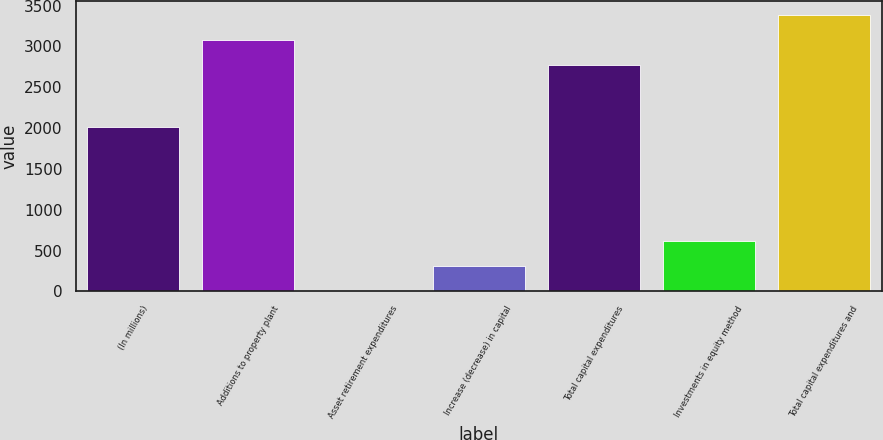Convert chart. <chart><loc_0><loc_0><loc_500><loc_500><bar_chart><fcel>(In millions)<fcel>Additions to property plant<fcel>Asset retirement expenditures<fcel>Increase (decrease) in capital<fcel>Total capital expenditures<fcel>Investments in equity method<fcel>Total capital expenditures and<nl><fcel>2016<fcel>3076.3<fcel>6<fcel>311.3<fcel>2771<fcel>616.6<fcel>3381.6<nl></chart> 